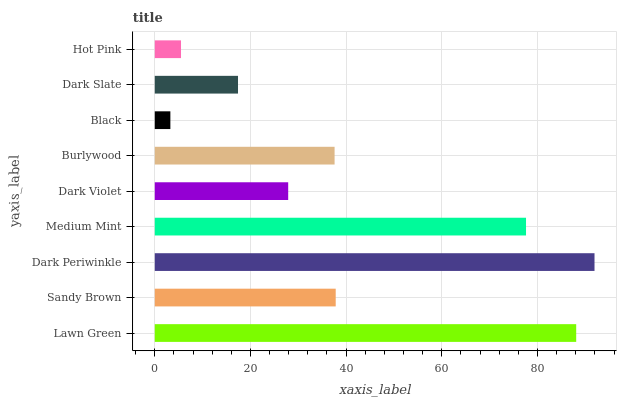Is Black the minimum?
Answer yes or no. Yes. Is Dark Periwinkle the maximum?
Answer yes or no. Yes. Is Sandy Brown the minimum?
Answer yes or no. No. Is Sandy Brown the maximum?
Answer yes or no. No. Is Lawn Green greater than Sandy Brown?
Answer yes or no. Yes. Is Sandy Brown less than Lawn Green?
Answer yes or no. Yes. Is Sandy Brown greater than Lawn Green?
Answer yes or no. No. Is Lawn Green less than Sandy Brown?
Answer yes or no. No. Is Burlywood the high median?
Answer yes or no. Yes. Is Burlywood the low median?
Answer yes or no. Yes. Is Dark Periwinkle the high median?
Answer yes or no. No. Is Dark Periwinkle the low median?
Answer yes or no. No. 